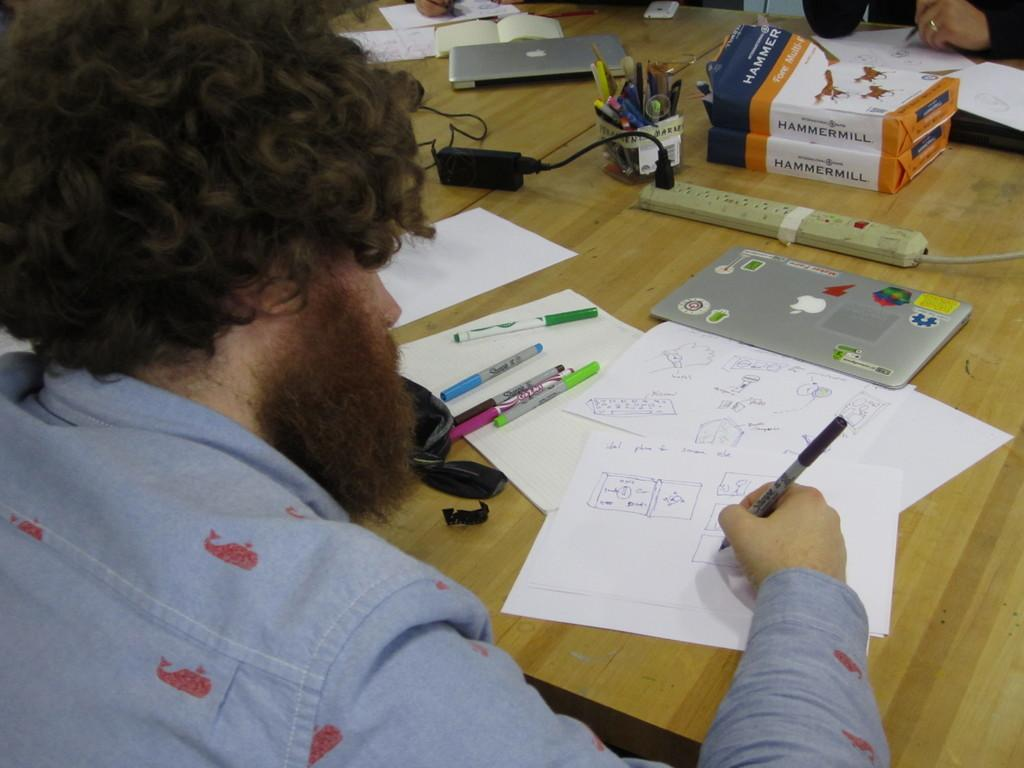What is the person holding in the image? The person is holding a pen. What is in front of the person? There is a table in front of the person. What can be seen on the table? Papers, pens, an extension board, packets, and laptops are on the table. Are there any other items on the table? Yes, there are other unspecified items on the table. What type of vest is the person wearing in the image? There is no vest visible in the image; the person is not wearing any clothing. Can you tell me who the person's partner is in the image? There is no partner present in the image; it only shows a person holding a pen and a table with various items. 